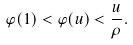Convert formula to latex. <formula><loc_0><loc_0><loc_500><loc_500>\varphi ( 1 ) < \varphi ( u ) < \frac { u } { \rho } .</formula> 